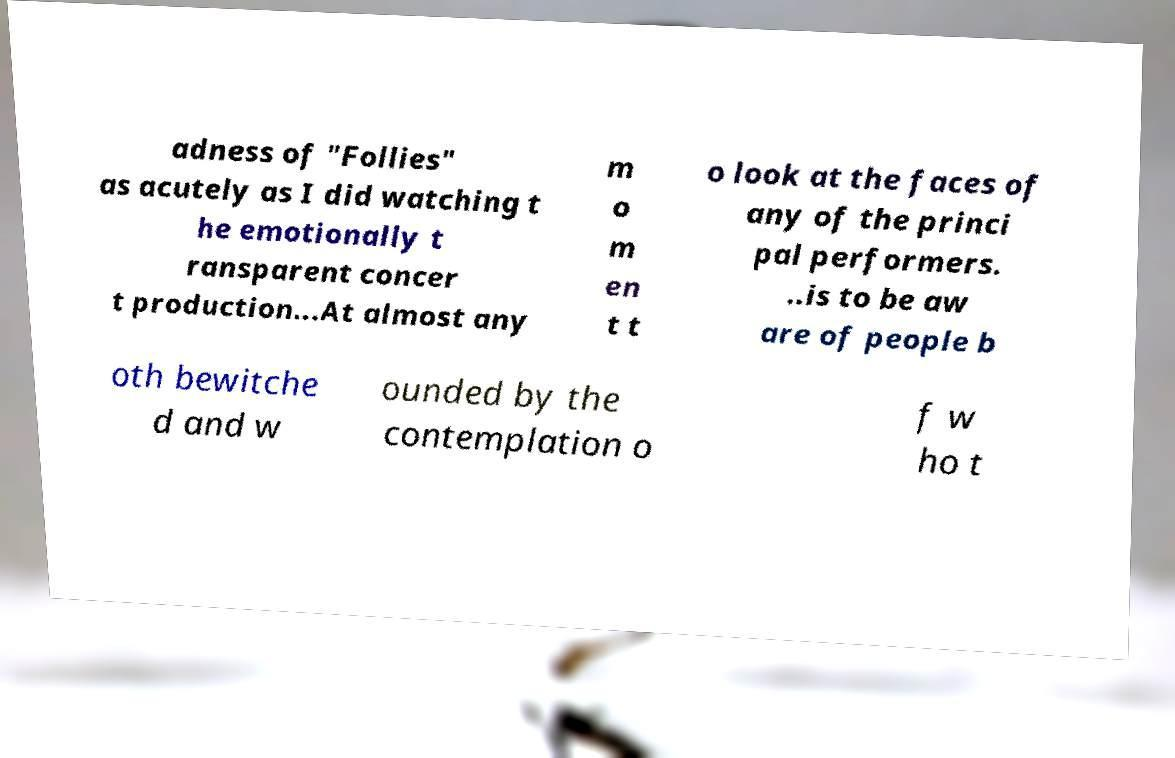Can you read and provide the text displayed in the image?This photo seems to have some interesting text. Can you extract and type it out for me? adness of "Follies" as acutely as I did watching t he emotionally t ransparent concer t production...At almost any m o m en t t o look at the faces of any of the princi pal performers. ..is to be aw are of people b oth bewitche d and w ounded by the contemplation o f w ho t 